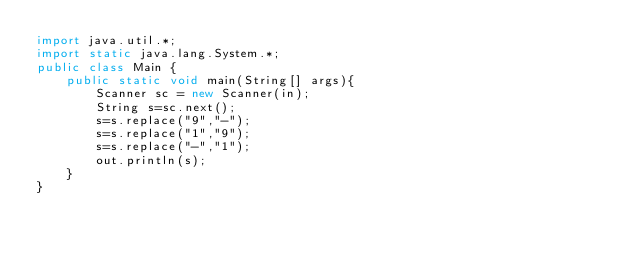<code> <loc_0><loc_0><loc_500><loc_500><_Java_>import java.util.*;
import static java.lang.System.*;
public class Main {
    public static void main(String[] args){
        Scanner sc = new Scanner(in);
        String s=sc.next();
        s=s.replace("9","-");
        s=s.replace("1","9");
        s=s.replace("-","1");
        out.println(s);
    }
}</code> 